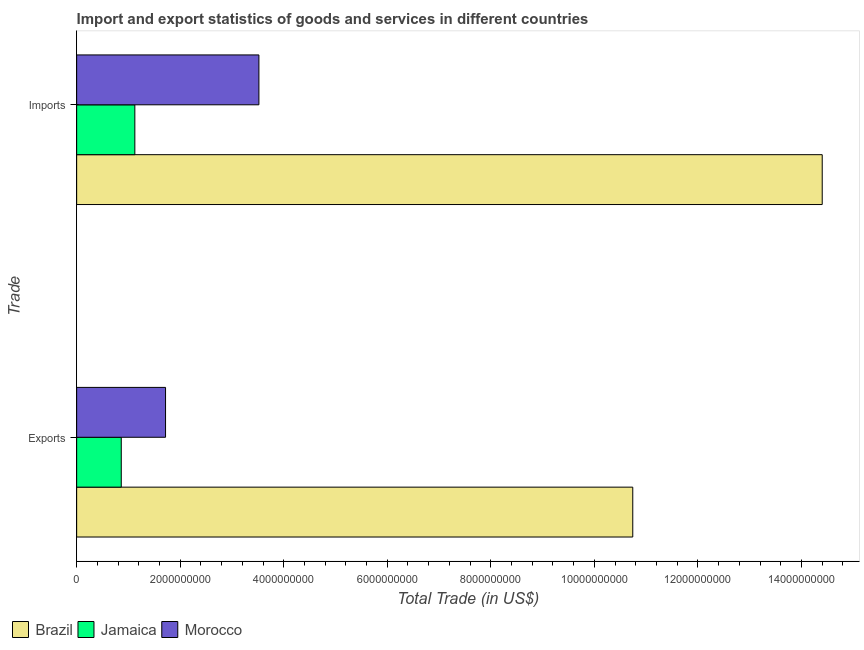How many different coloured bars are there?
Your response must be concise. 3. Are the number of bars per tick equal to the number of legend labels?
Make the answer very short. Yes. Are the number of bars on each tick of the Y-axis equal?
Keep it short and to the point. Yes. How many bars are there on the 1st tick from the top?
Ensure brevity in your answer.  3. How many bars are there on the 1st tick from the bottom?
Your answer should be very brief. 3. What is the label of the 1st group of bars from the top?
Ensure brevity in your answer.  Imports. What is the export of goods and services in Morocco?
Offer a very short reply. 1.72e+09. Across all countries, what is the maximum imports of goods and services?
Provide a succinct answer. 1.44e+1. Across all countries, what is the minimum imports of goods and services?
Provide a short and direct response. 1.12e+09. In which country was the imports of goods and services maximum?
Your answer should be compact. Brazil. In which country was the export of goods and services minimum?
Ensure brevity in your answer.  Jamaica. What is the total export of goods and services in the graph?
Your answer should be compact. 1.33e+1. What is the difference between the export of goods and services in Brazil and that in Jamaica?
Provide a succinct answer. 9.88e+09. What is the difference between the export of goods and services in Morocco and the imports of goods and services in Brazil?
Offer a very short reply. -1.27e+1. What is the average export of goods and services per country?
Offer a very short reply. 4.44e+09. What is the difference between the export of goods and services and imports of goods and services in Brazil?
Your answer should be compact. -3.66e+09. In how many countries, is the imports of goods and services greater than 6800000000 US$?
Your answer should be compact. 1. What is the ratio of the imports of goods and services in Morocco to that in Brazil?
Offer a very short reply. 0.24. Is the export of goods and services in Jamaica less than that in Morocco?
Make the answer very short. Yes. In how many countries, is the export of goods and services greater than the average export of goods and services taken over all countries?
Your answer should be compact. 1. What does the 1st bar from the top in Imports represents?
Ensure brevity in your answer.  Morocco. What does the 2nd bar from the bottom in Imports represents?
Offer a terse response. Jamaica. How many bars are there?
Make the answer very short. 6. How many countries are there in the graph?
Offer a very short reply. 3. Are the values on the major ticks of X-axis written in scientific E-notation?
Offer a terse response. No. What is the title of the graph?
Ensure brevity in your answer.  Import and export statistics of goods and services in different countries. What is the label or title of the X-axis?
Offer a terse response. Total Trade (in US$). What is the label or title of the Y-axis?
Your response must be concise. Trade. What is the Total Trade (in US$) of Brazil in Exports?
Your answer should be compact. 1.07e+1. What is the Total Trade (in US$) in Jamaica in Exports?
Give a very brief answer. 8.62e+08. What is the Total Trade (in US$) of Morocco in Exports?
Your answer should be very brief. 1.72e+09. What is the Total Trade (in US$) in Brazil in Imports?
Offer a terse response. 1.44e+1. What is the Total Trade (in US$) of Jamaica in Imports?
Make the answer very short. 1.12e+09. What is the Total Trade (in US$) of Morocco in Imports?
Your response must be concise. 3.52e+09. Across all Trade, what is the maximum Total Trade (in US$) in Brazil?
Offer a terse response. 1.44e+1. Across all Trade, what is the maximum Total Trade (in US$) in Jamaica?
Provide a short and direct response. 1.12e+09. Across all Trade, what is the maximum Total Trade (in US$) of Morocco?
Ensure brevity in your answer.  3.52e+09. Across all Trade, what is the minimum Total Trade (in US$) in Brazil?
Give a very brief answer. 1.07e+1. Across all Trade, what is the minimum Total Trade (in US$) in Jamaica?
Ensure brevity in your answer.  8.62e+08. Across all Trade, what is the minimum Total Trade (in US$) in Morocco?
Make the answer very short. 1.72e+09. What is the total Total Trade (in US$) in Brazil in the graph?
Ensure brevity in your answer.  2.51e+1. What is the total Total Trade (in US$) in Jamaica in the graph?
Offer a terse response. 1.99e+09. What is the total Total Trade (in US$) of Morocco in the graph?
Make the answer very short. 5.24e+09. What is the difference between the Total Trade (in US$) of Brazil in Exports and that in Imports?
Give a very brief answer. -3.66e+09. What is the difference between the Total Trade (in US$) of Jamaica in Exports and that in Imports?
Provide a short and direct response. -2.62e+08. What is the difference between the Total Trade (in US$) in Morocco in Exports and that in Imports?
Offer a very short reply. -1.80e+09. What is the difference between the Total Trade (in US$) in Brazil in Exports and the Total Trade (in US$) in Jamaica in Imports?
Make the answer very short. 9.62e+09. What is the difference between the Total Trade (in US$) in Brazil in Exports and the Total Trade (in US$) in Morocco in Imports?
Make the answer very short. 7.22e+09. What is the difference between the Total Trade (in US$) of Jamaica in Exports and the Total Trade (in US$) of Morocco in Imports?
Your answer should be very brief. -2.66e+09. What is the average Total Trade (in US$) of Brazil per Trade?
Your answer should be very brief. 1.26e+1. What is the average Total Trade (in US$) of Jamaica per Trade?
Make the answer very short. 9.93e+08. What is the average Total Trade (in US$) in Morocco per Trade?
Your answer should be very brief. 2.62e+09. What is the difference between the Total Trade (in US$) of Brazil and Total Trade (in US$) of Jamaica in Exports?
Offer a very short reply. 9.88e+09. What is the difference between the Total Trade (in US$) of Brazil and Total Trade (in US$) of Morocco in Exports?
Your answer should be very brief. 9.02e+09. What is the difference between the Total Trade (in US$) of Jamaica and Total Trade (in US$) of Morocco in Exports?
Give a very brief answer. -8.56e+08. What is the difference between the Total Trade (in US$) of Brazil and Total Trade (in US$) of Jamaica in Imports?
Your answer should be compact. 1.33e+1. What is the difference between the Total Trade (in US$) in Brazil and Total Trade (in US$) in Morocco in Imports?
Your answer should be compact. 1.09e+1. What is the difference between the Total Trade (in US$) in Jamaica and Total Trade (in US$) in Morocco in Imports?
Ensure brevity in your answer.  -2.40e+09. What is the ratio of the Total Trade (in US$) in Brazil in Exports to that in Imports?
Your answer should be very brief. 0.75. What is the ratio of the Total Trade (in US$) of Jamaica in Exports to that in Imports?
Make the answer very short. 0.77. What is the ratio of the Total Trade (in US$) in Morocco in Exports to that in Imports?
Your answer should be compact. 0.49. What is the difference between the highest and the second highest Total Trade (in US$) of Brazil?
Your answer should be compact. 3.66e+09. What is the difference between the highest and the second highest Total Trade (in US$) of Jamaica?
Offer a terse response. 2.62e+08. What is the difference between the highest and the second highest Total Trade (in US$) of Morocco?
Keep it short and to the point. 1.80e+09. What is the difference between the highest and the lowest Total Trade (in US$) in Brazil?
Make the answer very short. 3.66e+09. What is the difference between the highest and the lowest Total Trade (in US$) in Jamaica?
Provide a short and direct response. 2.62e+08. What is the difference between the highest and the lowest Total Trade (in US$) of Morocco?
Your answer should be very brief. 1.80e+09. 